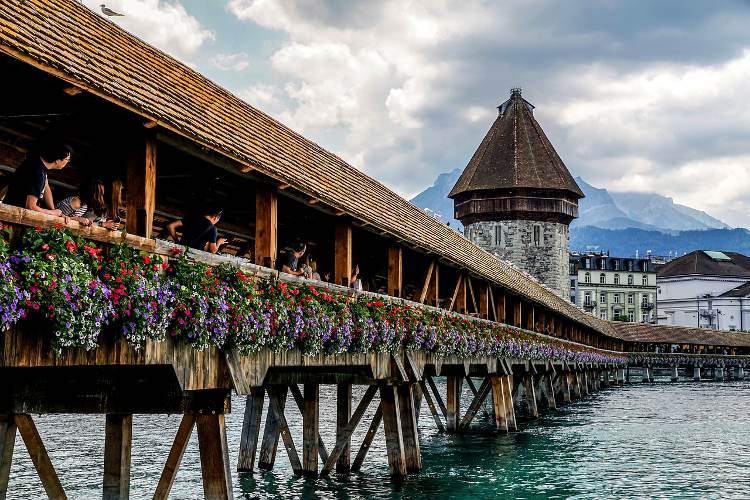Can you explain the architectural style of the bridge and its tower? Certainly! The Chapel Bridge is constructed in a covered wooden truss style, which was common in the medieval periods of Europe for providing protection against the elements. The Water Tower, octagonal in shape, combines both practical defensive features and aesthetic elements typical of the 13th-century architectural style. Its wooden pathway, coupled with the stone base of the tower, illustrates a fusion of building materials common in Swiss architecture. 